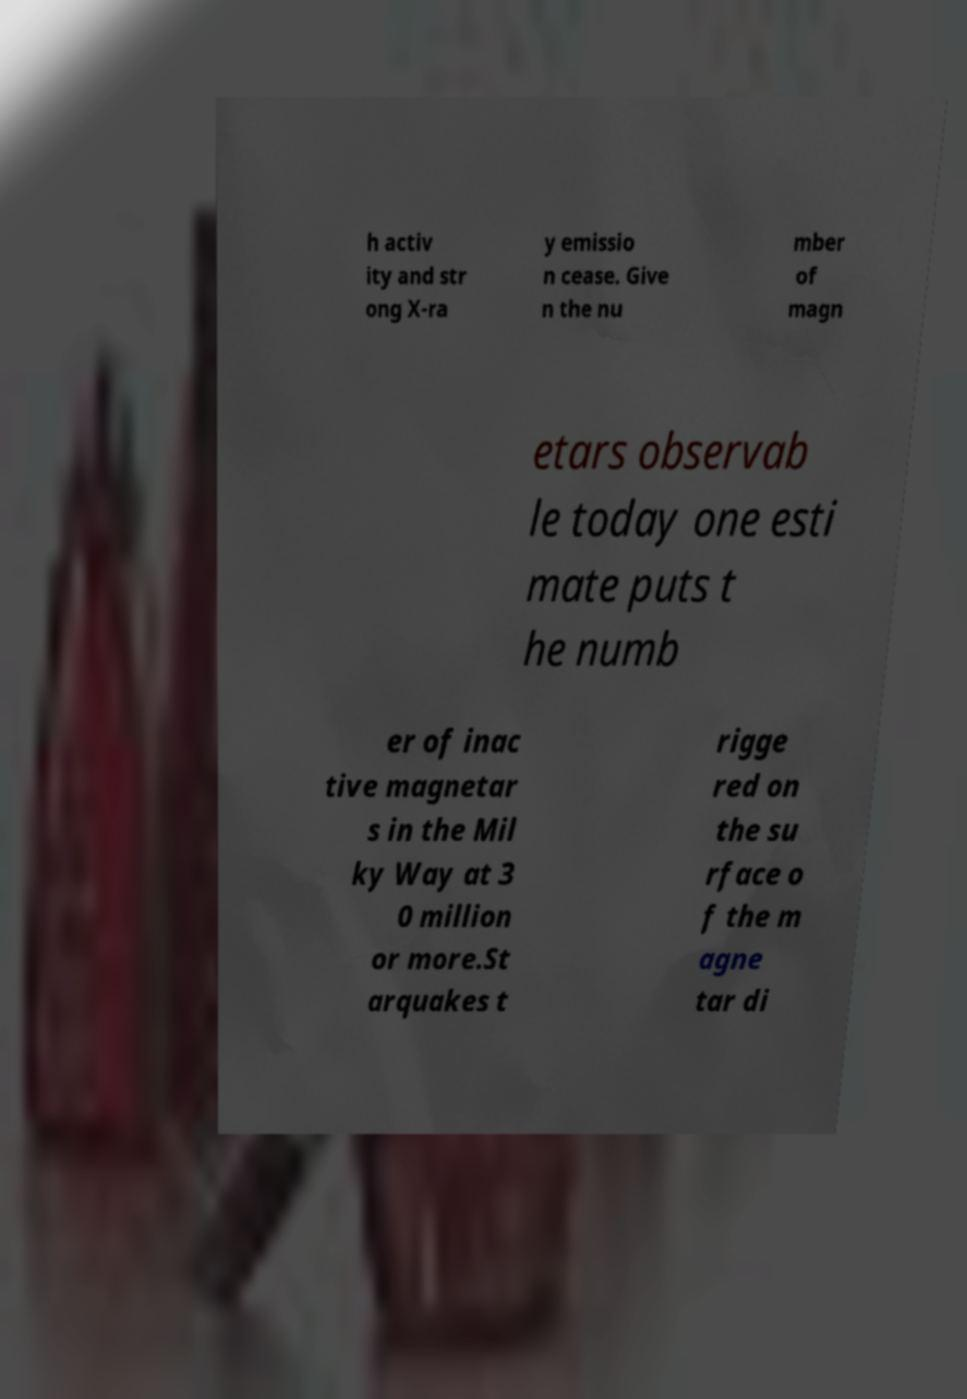There's text embedded in this image that I need extracted. Can you transcribe it verbatim? h activ ity and str ong X-ra y emissio n cease. Give n the nu mber of magn etars observab le today one esti mate puts t he numb er of inac tive magnetar s in the Mil ky Way at 3 0 million or more.St arquakes t rigge red on the su rface o f the m agne tar di 